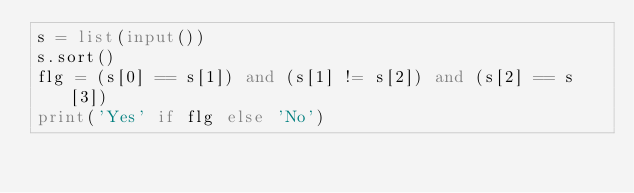Convert code to text. <code><loc_0><loc_0><loc_500><loc_500><_Python_>s = list(input())
s.sort()
flg = (s[0] == s[1]) and (s[1] != s[2]) and (s[2] == s[3])
print('Yes' if flg else 'No')
</code> 